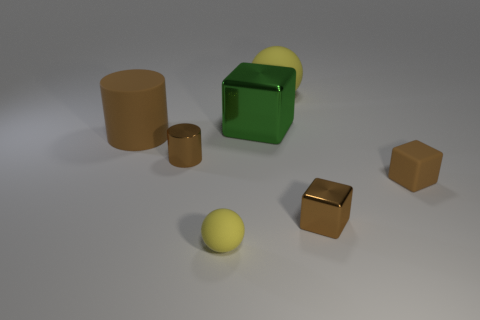Add 2 green shiny cubes. How many objects exist? 9 Subtract all cubes. How many objects are left? 4 Subtract 0 blue cubes. How many objects are left? 7 Subtract all rubber cubes. Subtract all balls. How many objects are left? 4 Add 2 brown metallic cylinders. How many brown metallic cylinders are left? 3 Add 7 yellow matte cylinders. How many yellow matte cylinders exist? 7 